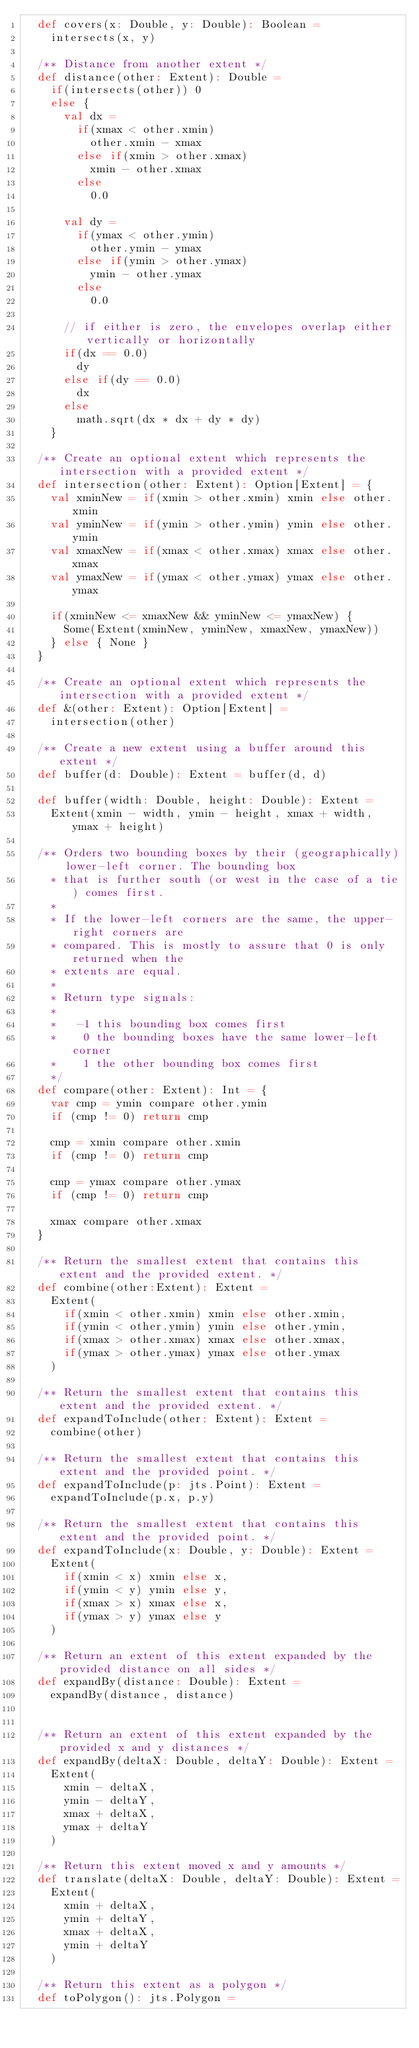<code> <loc_0><loc_0><loc_500><loc_500><_Scala_>  def covers(x: Double, y: Double): Boolean =
    intersects(x, y)

  /** Distance from another extent */
  def distance(other: Extent): Double =
    if(intersects(other)) 0
    else {
      val dx =
        if(xmax < other.xmin)
          other.xmin - xmax
        else if(xmin > other.xmax)
          xmin - other.xmax
        else
          0.0

      val dy =
        if(ymax < other.ymin)
          other.ymin - ymax
        else if(ymin > other.ymax)
          ymin - other.ymax
        else
          0.0

      // if either is zero, the envelopes overlap either vertically or horizontally
      if(dx == 0.0)
        dy
      else if(dy == 0.0)
        dx
      else
        math.sqrt(dx * dx + dy * dy)
    }

  /** Create an optional extent which represents the intersection with a provided extent */
  def intersection(other: Extent): Option[Extent] = {
    val xminNew = if(xmin > other.xmin) xmin else other.xmin
    val yminNew = if(ymin > other.ymin) ymin else other.ymin
    val xmaxNew = if(xmax < other.xmax) xmax else other.xmax
    val ymaxNew = if(ymax < other.ymax) ymax else other.ymax

    if(xminNew <= xmaxNew && yminNew <= ymaxNew) {
      Some(Extent(xminNew, yminNew, xmaxNew, ymaxNew))
    } else { None }
  }

  /** Create an optional extent which represents the intersection with a provided extent */
  def &(other: Extent): Option[Extent] =
    intersection(other)

  /** Create a new extent using a buffer around this extent */
  def buffer(d: Double): Extent = buffer(d, d)

  def buffer(width: Double, height: Double): Extent =
    Extent(xmin - width, ymin - height, xmax + width, ymax + height)

  /** Orders two bounding boxes by their (geographically) lower-left corner. The bounding box
    * that is further south (or west in the case of a tie) comes first.
    *
    * If the lower-left corners are the same, the upper-right corners are
    * compared. This is mostly to assure that 0 is only returned when the
    * extents are equal.
    *
    * Return type signals:
    *
    *   -1 this bounding box comes first
    *    0 the bounding boxes have the same lower-left corner
    *    1 the other bounding box comes first
    */
  def compare(other: Extent): Int = {
    var cmp = ymin compare other.ymin
    if (cmp != 0) return cmp

    cmp = xmin compare other.xmin
    if (cmp != 0) return cmp

    cmp = ymax compare other.ymax
    if (cmp != 0) return cmp

    xmax compare other.xmax
  }

  /** Return the smallest extent that contains this extent and the provided extent. */
  def combine(other:Extent): Extent =
    Extent(
      if(xmin < other.xmin) xmin else other.xmin,
      if(ymin < other.ymin) ymin else other.ymin,
      if(xmax > other.xmax) xmax else other.xmax,
      if(ymax > other.ymax) ymax else other.ymax
    )

  /** Return the smallest extent that contains this extent and the provided extent. */
  def expandToInclude(other: Extent): Extent =
    combine(other)

  /** Return the smallest extent that contains this extent and the provided point. */
  def expandToInclude(p: jts.Point): Extent =
    expandToInclude(p.x, p.y)

  /** Return the smallest extent that contains this extent and the provided point. */
  def expandToInclude(x: Double, y: Double): Extent =
    Extent(
      if(xmin < x) xmin else x,
      if(ymin < y) ymin else y,
      if(xmax > x) xmax else x,
      if(ymax > y) ymax else y
    )

  /** Return an extent of this extent expanded by the provided distance on all sides */
  def expandBy(distance: Double): Extent =
    expandBy(distance, distance)


  /** Return an extent of this extent expanded by the provided x and y distances */
  def expandBy(deltaX: Double, deltaY: Double): Extent =
    Extent(
      xmin - deltaX,
      ymin - deltaY,
      xmax + deltaX,
      ymax + deltaY
    )

  /** Return this extent moved x and y amounts */
  def translate(deltaX: Double, deltaY: Double): Extent =
    Extent(
      xmin + deltaX,
      ymin + deltaY,
      xmax + deltaX,
      ymin + deltaY
    )

  /** Return this extent as a polygon */
  def toPolygon(): jts.Polygon =</code> 